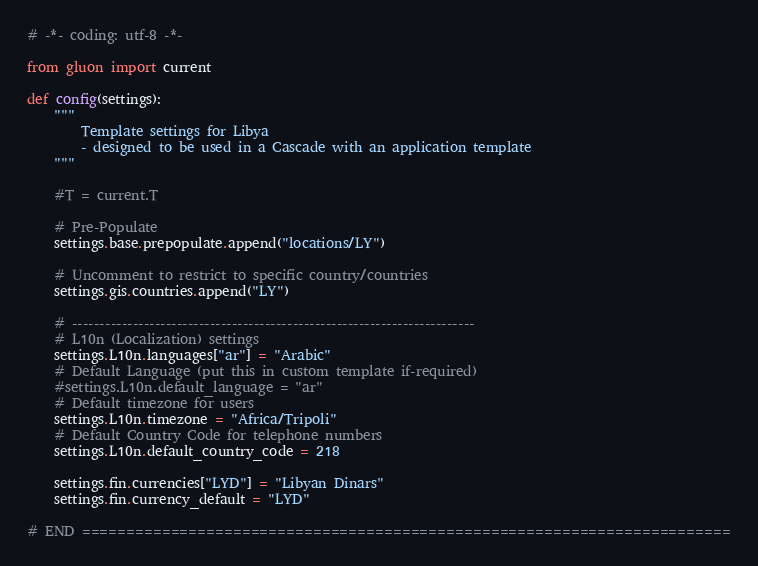<code> <loc_0><loc_0><loc_500><loc_500><_Python_># -*- coding: utf-8 -*-

from gluon import current

def config(settings):
    """
        Template settings for Libya
        - designed to be used in a Cascade with an application template
    """

    #T = current.T

    # Pre-Populate
    settings.base.prepopulate.append("locations/LY")

    # Uncomment to restrict to specific country/countries
    settings.gis.countries.append("LY")

    # -------------------------------------------------------------------------
    # L10n (Localization) settings
    settings.L10n.languages["ar"] = "Arabic"
    # Default Language (put this in custom template if-required)
    #settings.L10n.default_language = "ar"
    # Default timezone for users
    settings.L10n.timezone = "Africa/Tripoli"
    # Default Country Code for telephone numbers
    settings.L10n.default_country_code = 218

    settings.fin.currencies["LYD"] = "Libyan Dinars"
    settings.fin.currency_default = "LYD"

# END =========================================================================
</code> 